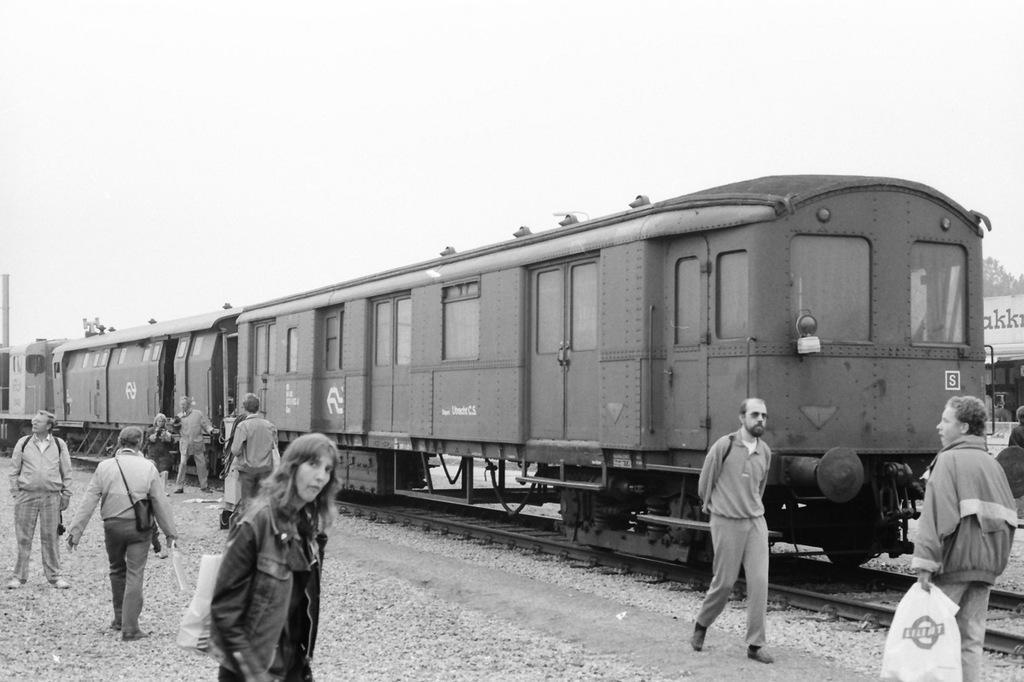Could you give a brief overview of what you see in this image? In this picture I can see few persons on either side of this image, in the middle there is a train, at the top there is the sky. This image is in black and white color. 